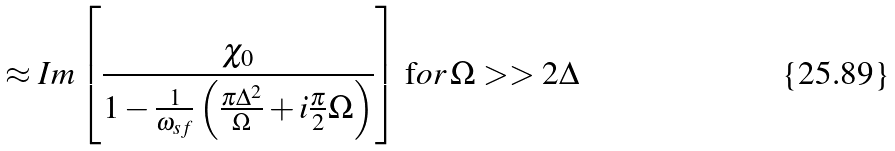Convert formula to latex. <formula><loc_0><loc_0><loc_500><loc_500>\approx I m \left [ \frac { \chi _ { 0 } } { 1 - \frac { 1 } { \omega _ { s f } } \left ( \frac { \pi \Delta ^ { 2 } } { \Omega } + i \frac { \pi } { 2 } \Omega \right ) } \right ] \, { \text  for}\, \Omega>>2\Delta</formula> 